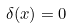<formula> <loc_0><loc_0><loc_500><loc_500>\delta ( x ) = 0</formula> 